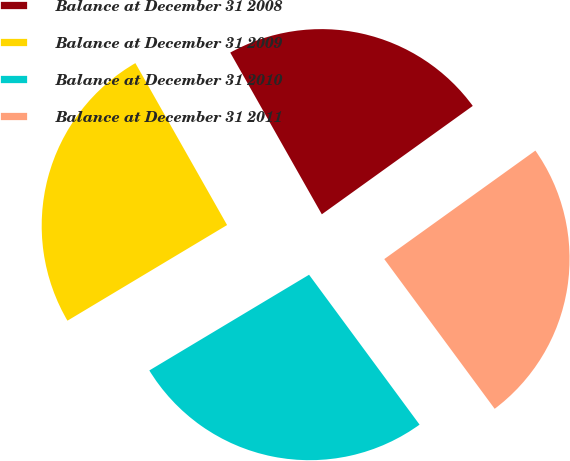Convert chart. <chart><loc_0><loc_0><loc_500><loc_500><pie_chart><fcel>Balance at December 31 2008<fcel>Balance at December 31 2009<fcel>Balance at December 31 2010<fcel>Balance at December 31 2011<nl><fcel>23.29%<fcel>25.39%<fcel>26.52%<fcel>24.8%<nl></chart> 